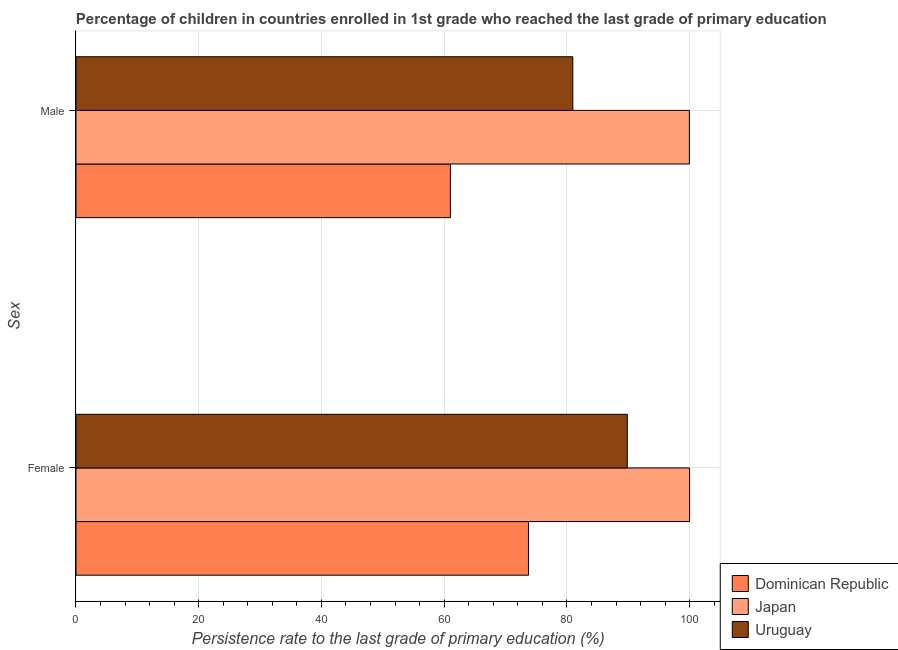How many different coloured bars are there?
Keep it short and to the point. 3. How many groups of bars are there?
Provide a succinct answer. 2. Are the number of bars per tick equal to the number of legend labels?
Ensure brevity in your answer.  Yes. What is the persistence rate of male students in Dominican Republic?
Your answer should be very brief. 61.01. Across all countries, what is the maximum persistence rate of female students?
Your answer should be very brief. 99.99. Across all countries, what is the minimum persistence rate of male students?
Keep it short and to the point. 61.01. In which country was the persistence rate of female students minimum?
Keep it short and to the point. Dominican Republic. What is the total persistence rate of female students in the graph?
Your answer should be compact. 263.57. What is the difference between the persistence rate of male students in Uruguay and that in Japan?
Your response must be concise. -19. What is the difference between the persistence rate of female students in Uruguay and the persistence rate of male students in Japan?
Provide a short and direct response. -10.12. What is the average persistence rate of male students per country?
Make the answer very short. 80.64. What is the difference between the persistence rate of male students and persistence rate of female students in Japan?
Offer a very short reply. -0.03. What is the ratio of the persistence rate of female students in Uruguay to that in Japan?
Ensure brevity in your answer.  0.9. Is the persistence rate of male students in Japan less than that in Dominican Republic?
Make the answer very short. No. In how many countries, is the persistence rate of male students greater than the average persistence rate of male students taken over all countries?
Make the answer very short. 2. What does the 3rd bar from the top in Male represents?
Provide a succinct answer. Dominican Republic. What does the 3rd bar from the bottom in Female represents?
Your answer should be compact. Uruguay. Are all the bars in the graph horizontal?
Ensure brevity in your answer.  Yes. How many countries are there in the graph?
Keep it short and to the point. 3. Are the values on the major ticks of X-axis written in scientific E-notation?
Give a very brief answer. No. Does the graph contain any zero values?
Keep it short and to the point. No. Does the graph contain grids?
Your response must be concise. Yes. Where does the legend appear in the graph?
Ensure brevity in your answer.  Bottom right. What is the title of the graph?
Provide a succinct answer. Percentage of children in countries enrolled in 1st grade who reached the last grade of primary education. Does "Tonga" appear as one of the legend labels in the graph?
Provide a succinct answer. No. What is the label or title of the X-axis?
Give a very brief answer. Persistence rate to the last grade of primary education (%). What is the label or title of the Y-axis?
Your answer should be very brief. Sex. What is the Persistence rate to the last grade of primary education (%) of Dominican Republic in Female?
Provide a short and direct response. 73.74. What is the Persistence rate to the last grade of primary education (%) of Japan in Female?
Your answer should be very brief. 99.99. What is the Persistence rate to the last grade of primary education (%) of Uruguay in Female?
Keep it short and to the point. 89.84. What is the Persistence rate to the last grade of primary education (%) in Dominican Republic in Male?
Your response must be concise. 61.01. What is the Persistence rate to the last grade of primary education (%) of Japan in Male?
Your answer should be very brief. 99.96. What is the Persistence rate to the last grade of primary education (%) of Uruguay in Male?
Your answer should be compact. 80.96. Across all Sex, what is the maximum Persistence rate to the last grade of primary education (%) of Dominican Republic?
Provide a short and direct response. 73.74. Across all Sex, what is the maximum Persistence rate to the last grade of primary education (%) in Japan?
Your answer should be compact. 99.99. Across all Sex, what is the maximum Persistence rate to the last grade of primary education (%) of Uruguay?
Your answer should be compact. 89.84. Across all Sex, what is the minimum Persistence rate to the last grade of primary education (%) of Dominican Republic?
Make the answer very short. 61.01. Across all Sex, what is the minimum Persistence rate to the last grade of primary education (%) in Japan?
Give a very brief answer. 99.96. Across all Sex, what is the minimum Persistence rate to the last grade of primary education (%) of Uruguay?
Provide a succinct answer. 80.96. What is the total Persistence rate to the last grade of primary education (%) of Dominican Republic in the graph?
Your answer should be very brief. 134.74. What is the total Persistence rate to the last grade of primary education (%) of Japan in the graph?
Your answer should be compact. 199.95. What is the total Persistence rate to the last grade of primary education (%) of Uruguay in the graph?
Keep it short and to the point. 170.8. What is the difference between the Persistence rate to the last grade of primary education (%) of Dominican Republic in Female and that in Male?
Make the answer very short. 12.73. What is the difference between the Persistence rate to the last grade of primary education (%) of Japan in Female and that in Male?
Your response must be concise. 0.03. What is the difference between the Persistence rate to the last grade of primary education (%) in Uruguay in Female and that in Male?
Give a very brief answer. 8.88. What is the difference between the Persistence rate to the last grade of primary education (%) in Dominican Republic in Female and the Persistence rate to the last grade of primary education (%) in Japan in Male?
Ensure brevity in your answer.  -26.22. What is the difference between the Persistence rate to the last grade of primary education (%) in Dominican Republic in Female and the Persistence rate to the last grade of primary education (%) in Uruguay in Male?
Offer a very short reply. -7.23. What is the difference between the Persistence rate to the last grade of primary education (%) of Japan in Female and the Persistence rate to the last grade of primary education (%) of Uruguay in Male?
Your response must be concise. 19.03. What is the average Persistence rate to the last grade of primary education (%) in Dominican Republic per Sex?
Your response must be concise. 67.37. What is the average Persistence rate to the last grade of primary education (%) in Japan per Sex?
Provide a succinct answer. 99.98. What is the average Persistence rate to the last grade of primary education (%) in Uruguay per Sex?
Give a very brief answer. 85.4. What is the difference between the Persistence rate to the last grade of primary education (%) in Dominican Republic and Persistence rate to the last grade of primary education (%) in Japan in Female?
Provide a short and direct response. -26.26. What is the difference between the Persistence rate to the last grade of primary education (%) of Dominican Republic and Persistence rate to the last grade of primary education (%) of Uruguay in Female?
Your answer should be very brief. -16.1. What is the difference between the Persistence rate to the last grade of primary education (%) of Japan and Persistence rate to the last grade of primary education (%) of Uruguay in Female?
Your answer should be very brief. 10.15. What is the difference between the Persistence rate to the last grade of primary education (%) of Dominican Republic and Persistence rate to the last grade of primary education (%) of Japan in Male?
Ensure brevity in your answer.  -38.95. What is the difference between the Persistence rate to the last grade of primary education (%) in Dominican Republic and Persistence rate to the last grade of primary education (%) in Uruguay in Male?
Give a very brief answer. -19.96. What is the difference between the Persistence rate to the last grade of primary education (%) of Japan and Persistence rate to the last grade of primary education (%) of Uruguay in Male?
Your answer should be compact. 19. What is the ratio of the Persistence rate to the last grade of primary education (%) in Dominican Republic in Female to that in Male?
Provide a short and direct response. 1.21. What is the ratio of the Persistence rate to the last grade of primary education (%) of Japan in Female to that in Male?
Provide a short and direct response. 1. What is the ratio of the Persistence rate to the last grade of primary education (%) in Uruguay in Female to that in Male?
Make the answer very short. 1.11. What is the difference between the highest and the second highest Persistence rate to the last grade of primary education (%) of Dominican Republic?
Your answer should be compact. 12.73. What is the difference between the highest and the second highest Persistence rate to the last grade of primary education (%) in Japan?
Keep it short and to the point. 0.03. What is the difference between the highest and the second highest Persistence rate to the last grade of primary education (%) in Uruguay?
Your response must be concise. 8.88. What is the difference between the highest and the lowest Persistence rate to the last grade of primary education (%) of Dominican Republic?
Provide a succinct answer. 12.73. What is the difference between the highest and the lowest Persistence rate to the last grade of primary education (%) of Japan?
Your answer should be compact. 0.03. What is the difference between the highest and the lowest Persistence rate to the last grade of primary education (%) of Uruguay?
Your answer should be very brief. 8.88. 